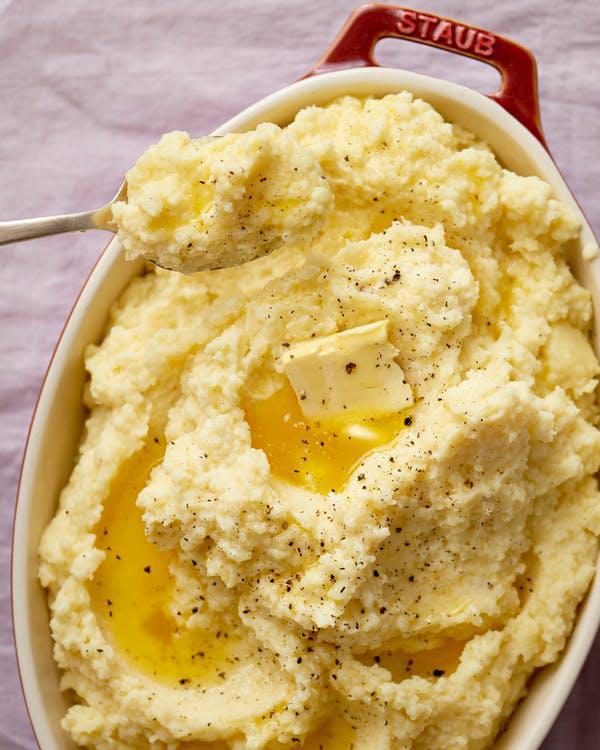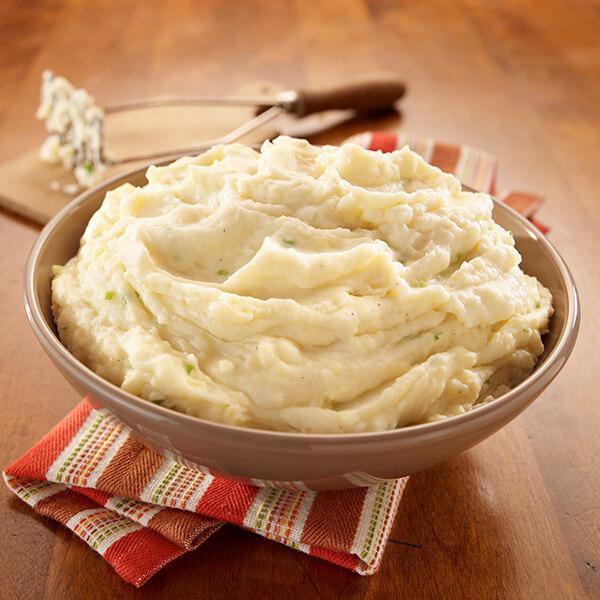The first image is the image on the left, the second image is the image on the right. Evaluate the accuracy of this statement regarding the images: "A eating utensil is visible in the right image.". Is it true? Answer yes or no. No. 